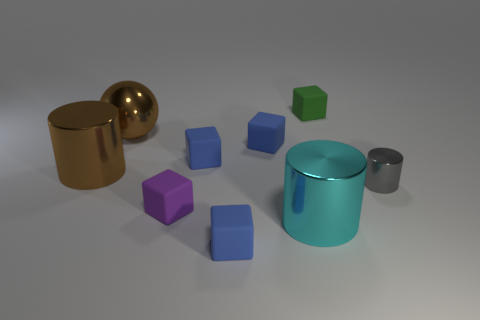Subtract all cyan cylinders. How many blue cubes are left? 3 Subtract 2 cubes. How many cubes are left? 3 Subtract all green cubes. How many cubes are left? 4 Subtract all green cubes. How many cubes are left? 4 Subtract all yellow blocks. Subtract all green cylinders. How many blocks are left? 5 Add 1 small blocks. How many objects exist? 10 Subtract all cubes. How many objects are left? 4 Add 2 gray shiny objects. How many gray shiny objects are left? 3 Add 4 tiny cyan matte cylinders. How many tiny cyan matte cylinders exist? 4 Subtract 1 cyan cylinders. How many objects are left? 8 